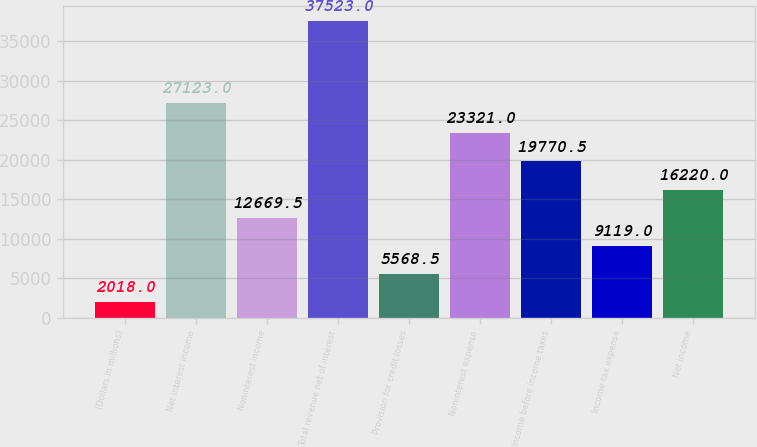Convert chart to OTSL. <chart><loc_0><loc_0><loc_500><loc_500><bar_chart><fcel>(Dollars in millions)<fcel>Net interest income<fcel>Noninterest income<fcel>Total revenue net of interest<fcel>Provision for credit losses<fcel>Noninterest expense<fcel>Income before income taxes<fcel>Income tax expense<fcel>Net income<nl><fcel>2018<fcel>27123<fcel>12669.5<fcel>37523<fcel>5568.5<fcel>23321<fcel>19770.5<fcel>9119<fcel>16220<nl></chart> 